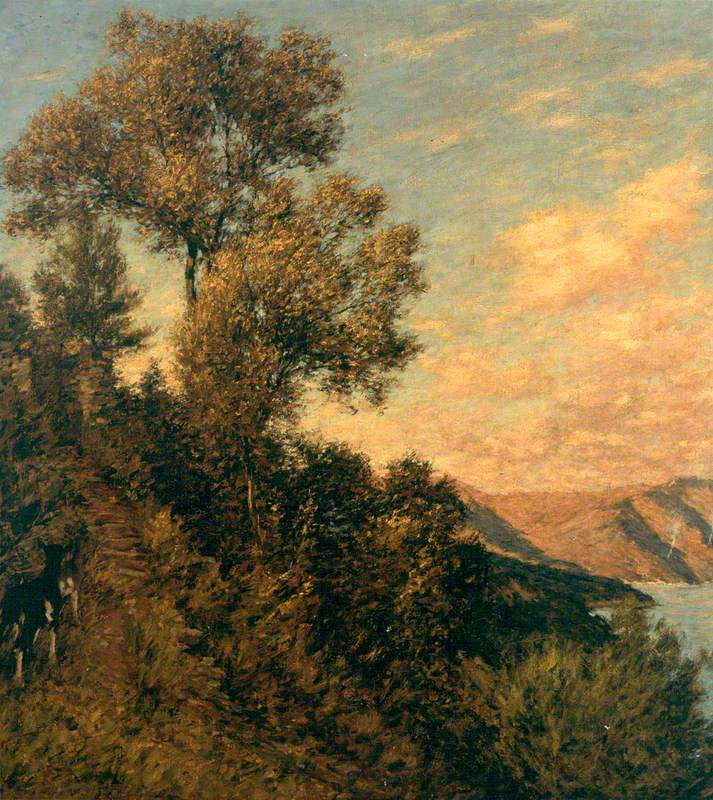What emotions do you think the artist was trying to evoke with the use of color in the painting? The artist's use of rich, dark greens for the foliage and soft, warm tones for the sky suggests an aim to evoke a sense of tranquility and warmth. The interplay of cool and warm colors is often used to create a harmonious and balanced effect, which can elicit a calm and contemplative mood in the viewer. 